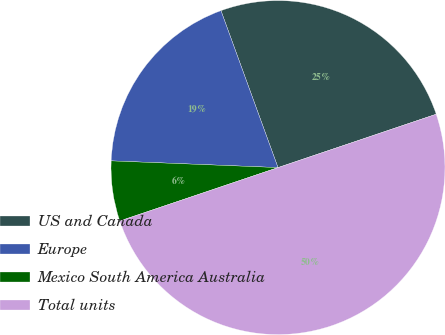<chart> <loc_0><loc_0><loc_500><loc_500><pie_chart><fcel>US and Canada<fcel>Europe<fcel>Mexico South America Australia<fcel>Total units<nl><fcel>25.37%<fcel>18.81%<fcel>5.82%<fcel>50.0%<nl></chart> 